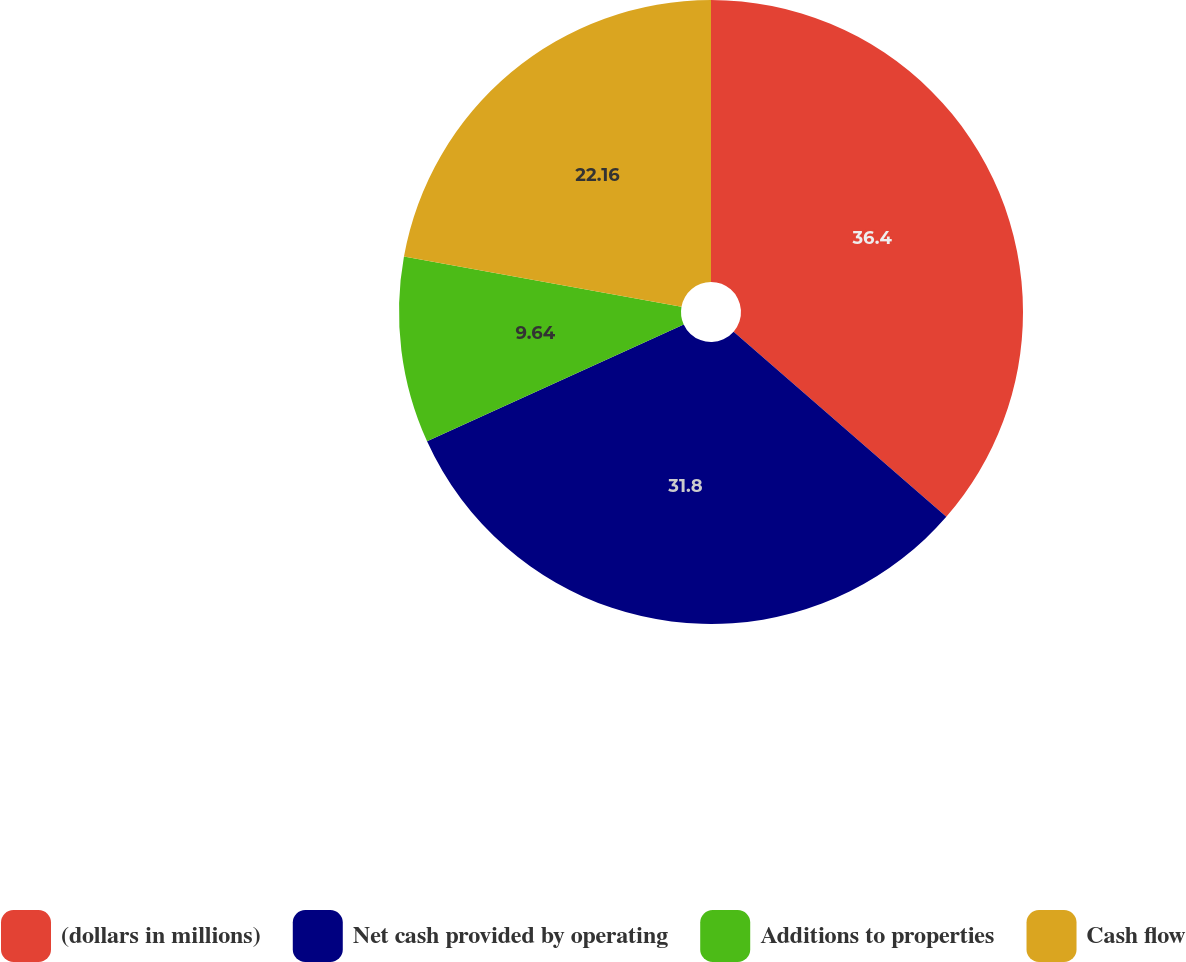<chart> <loc_0><loc_0><loc_500><loc_500><pie_chart><fcel>(dollars in millions)<fcel>Net cash provided by operating<fcel>Additions to properties<fcel>Cash flow<nl><fcel>36.4%<fcel>31.8%<fcel>9.64%<fcel>22.16%<nl></chart> 